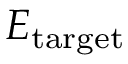<formula> <loc_0><loc_0><loc_500><loc_500>E _ { t \arg e t }</formula> 